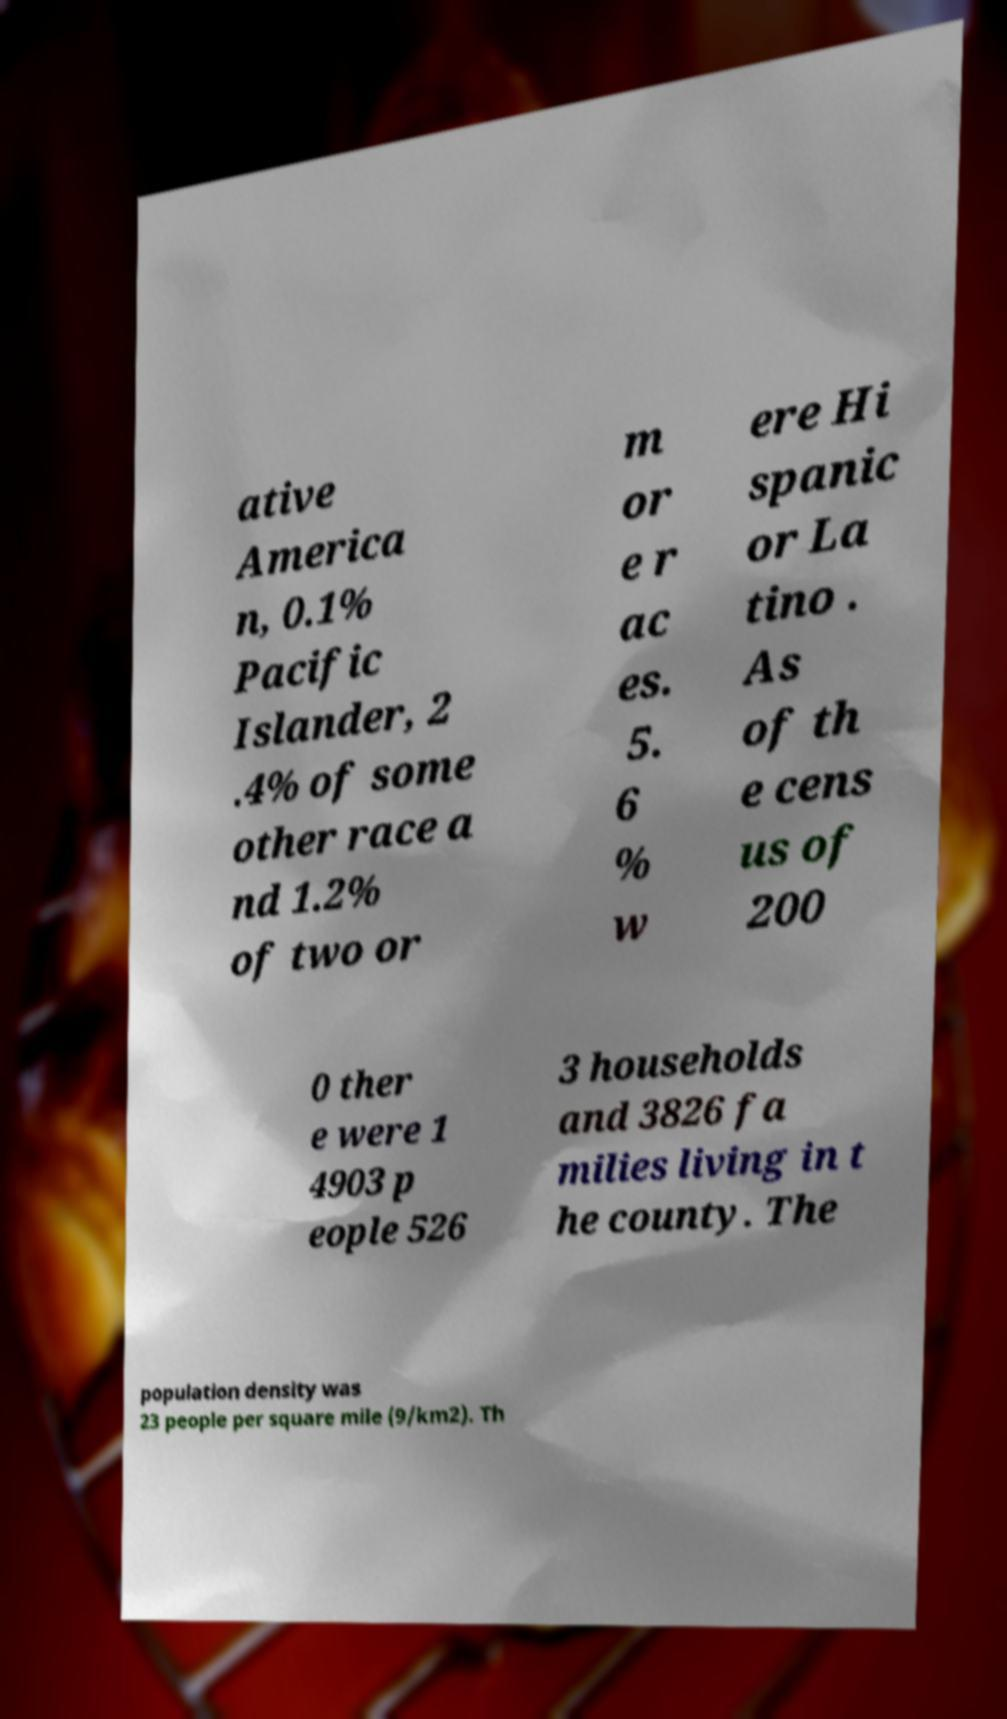Can you accurately transcribe the text from the provided image for me? ative America n, 0.1% Pacific Islander, 2 .4% of some other race a nd 1.2% of two or m or e r ac es. 5. 6 % w ere Hi spanic or La tino . As of th e cens us of 200 0 ther e were 1 4903 p eople 526 3 households and 3826 fa milies living in t he county. The population density was 23 people per square mile (9/km2). Th 